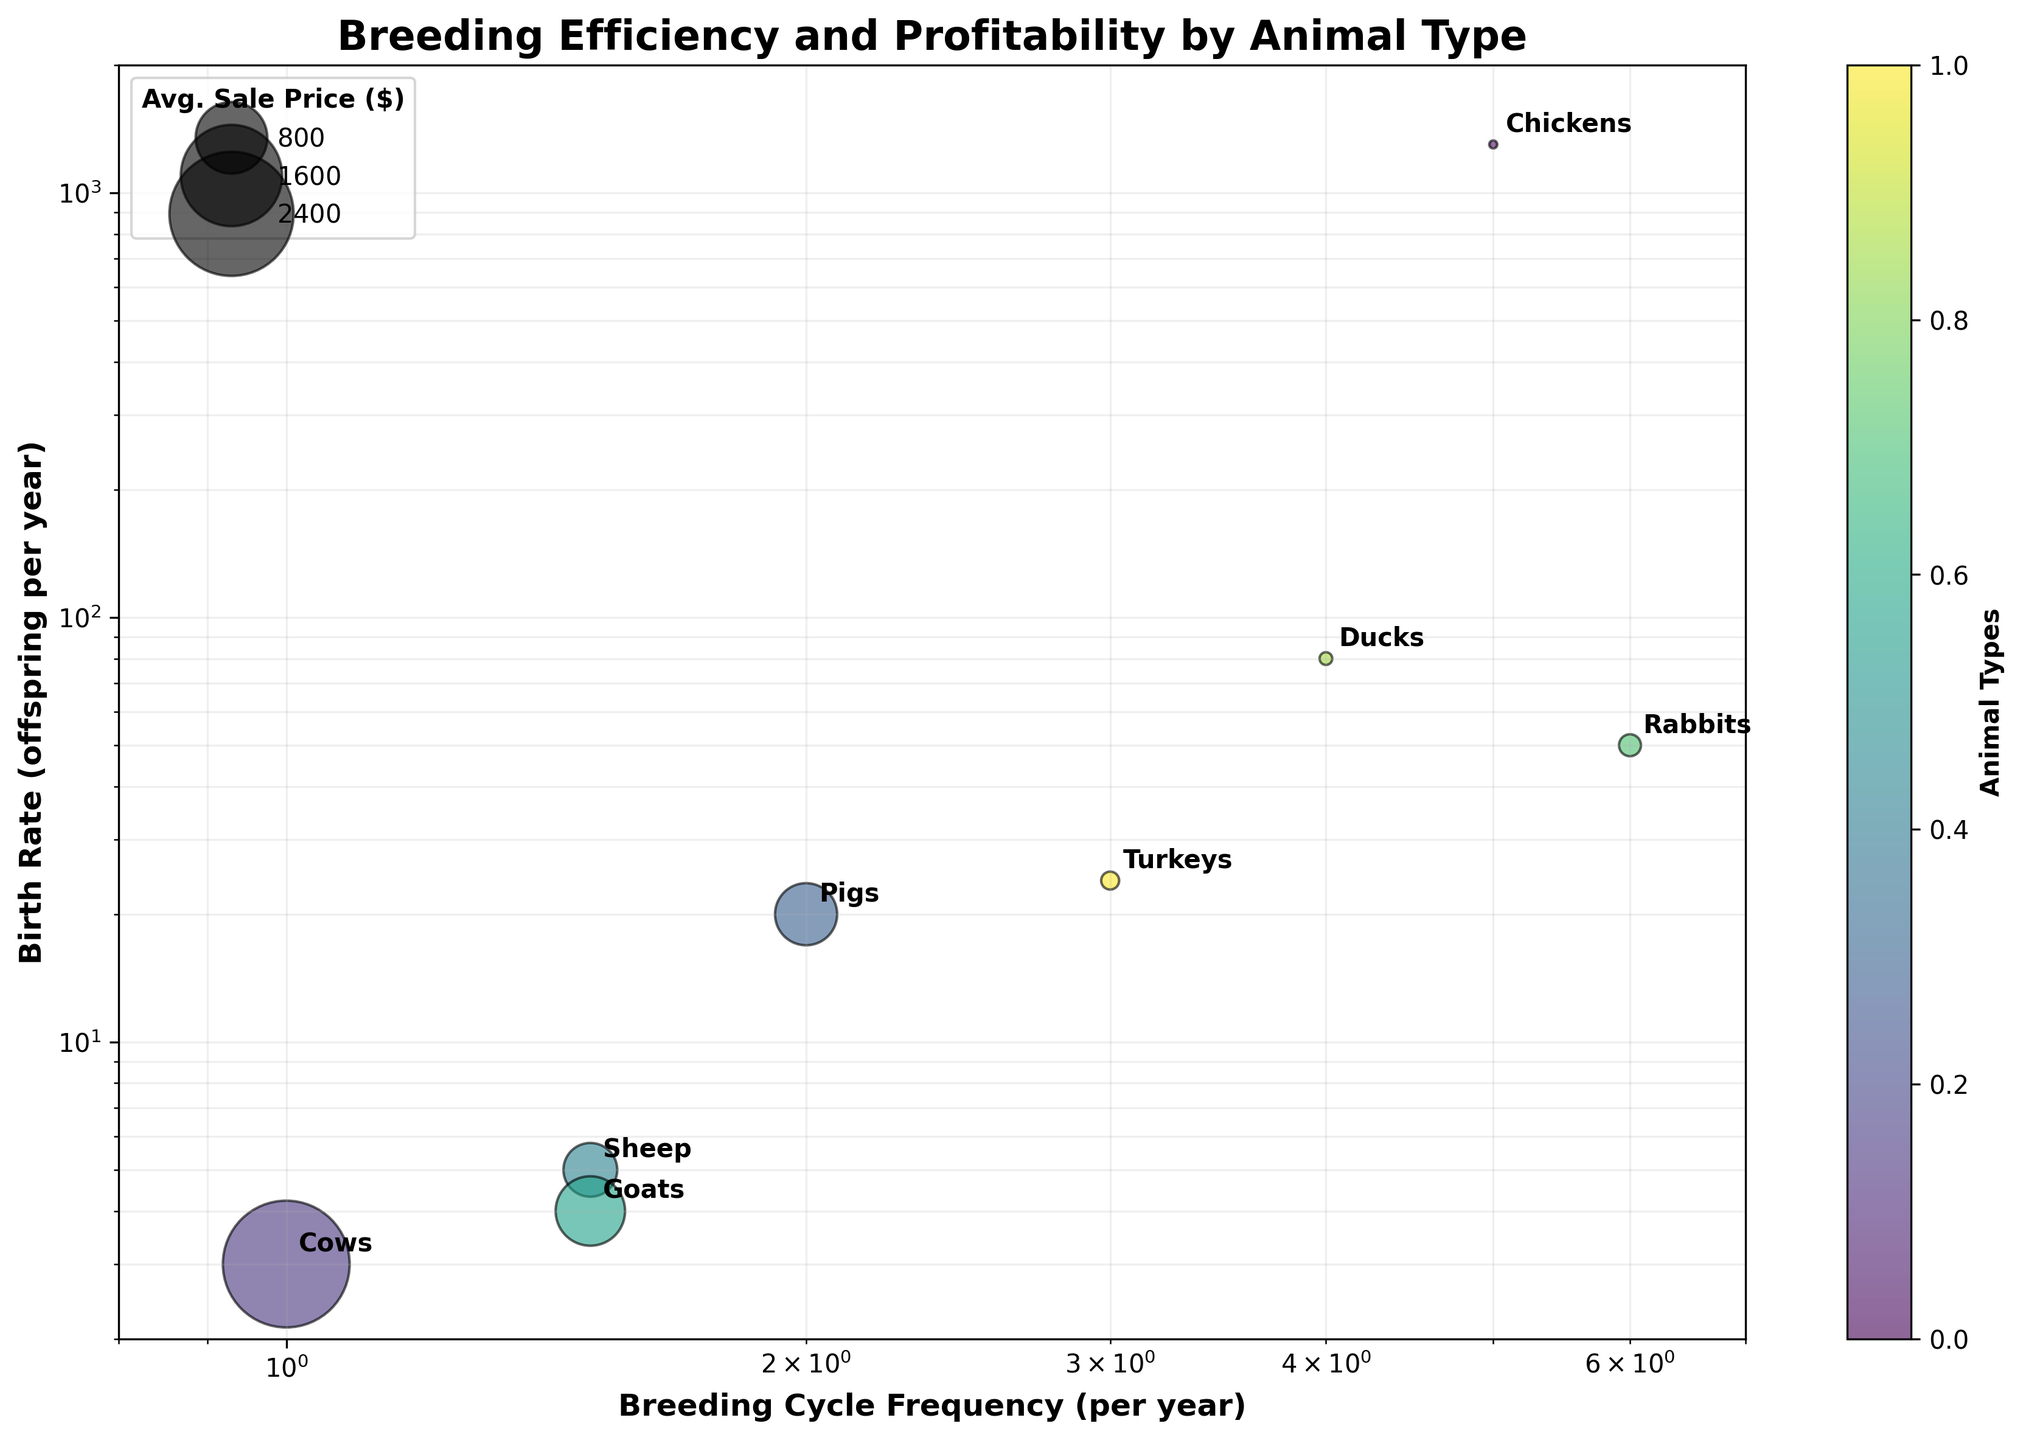What is the title of the chart? The title can be found on top of the chart.
Answer: "Breeding Efficiency and Profitability by Animal Type" How many different animal types are represented in the chart? Count the distinct animal types labeled on the chart.
Answer: 8 What are the labels of the x-axis and y-axis? Look at the label under the x-axis and the label next to the y-axis.
Answer: "Breeding Cycle Frequency (per year)" and "Birth Rate (offspring per year)" What does the size of the bubbles represent? Refer to the legend which explains the size of the bubbles.
Answer: "Avg. Sale Price ($)" What is the product of the breeding cycle frequency and birth rate for Turkeys? Multiply the breeding cycle frequency (3) by the birth rate (24) for Turkeys.
Answer: 72 Which animal type has the highest product of breeding cycle frequency and birth rate? Calculate the product of breeding cycle frequency and birth rate for each animal type, then compare them.
Answer: Chickens Which animal type has a higher birth rate, Ducks or Pigs? Compare the y-axis values for Ducks and Pigs.
Answer: Ducks Which has a larger average sale price, Goats or Rabbits? Compare the size of the bubbles or refer to the legend.
Answer: Goats Which animal type breeds most frequently per year? Look at the x-axis value to see the highest breeding cycle frequency.
Answer: Rabbits Which animal type has the largest bubble? Look for the largest bubble in terms of size.
Answer: "Cows" How does the birth rate of Pigs compare to that of Sheep? Compare the y-axis position of the bubbles for Pigs and Sheep.
Answer: Higher 